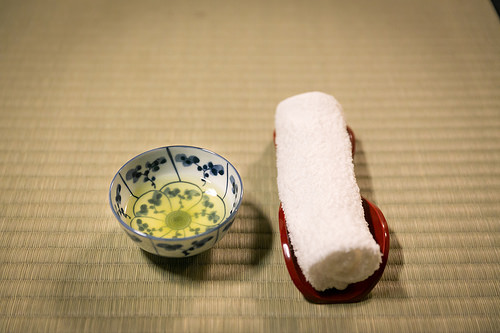<image>
Is the towel under the towel holder? No. The towel is not positioned under the towel holder. The vertical relationship between these objects is different. Where is the towel in relation to the dish? Is it next to the dish? Yes. The towel is positioned adjacent to the dish, located nearby in the same general area. 